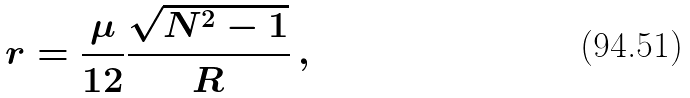Convert formula to latex. <formula><loc_0><loc_0><loc_500><loc_500>r = \frac { \mu } { 1 2 } \frac { \sqrt { N ^ { 2 } - 1 } } { R } \, ,</formula> 